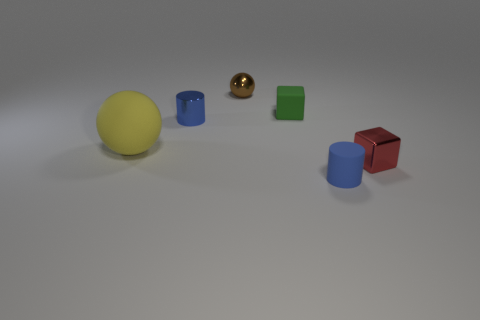What shape is the thing that is both on the left side of the red metallic cube and right of the green thing?
Your answer should be compact. Cylinder. The ball that is the same material as the green cube is what size?
Give a very brief answer. Large. There is a rubber cylinder; is its color the same as the cylinder that is behind the tiny red metallic thing?
Offer a terse response. Yes. The tiny thing that is both behind the red metallic block and in front of the tiny green object is made of what material?
Make the answer very short. Metal. Does the small blue object behind the blue rubber object have the same shape as the shiny object that is to the right of the small matte cylinder?
Your answer should be compact. No. Are any tiny blue spheres visible?
Offer a terse response. No. There is a rubber thing that is the same shape as the brown metal object; what color is it?
Offer a terse response. Yellow. The shiny cube that is the same size as the matte cube is what color?
Your response must be concise. Red. Do the tiny red object and the big yellow ball have the same material?
Offer a very short reply. No. What number of tiny rubber cubes are the same color as the large thing?
Make the answer very short. 0. 